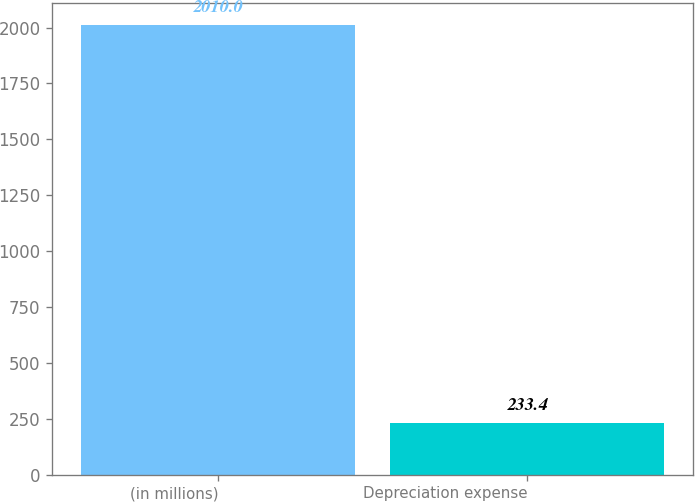Convert chart. <chart><loc_0><loc_0><loc_500><loc_500><bar_chart><fcel>(in millions)<fcel>Depreciation expense<nl><fcel>2010<fcel>233.4<nl></chart> 